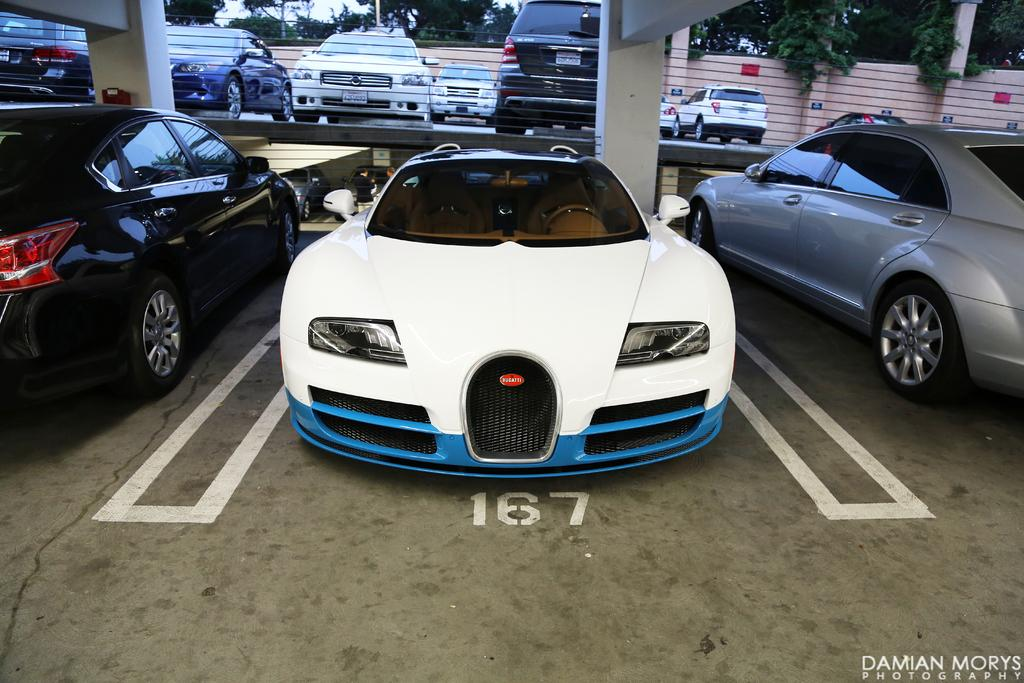What types of objects can be seen in the image? There are vehicles, pillars, a wall, boards, poles, trees, and text visible in the image. What part of the image is visible beneath the objects? The floor is visible in the image. What is present in the background of the image? The sky is visible in the image. Can you describe the text written at the bottom of the image? Unfortunately, the specific content of the text cannot be determined from the provided facts. How many beds are visible in the image? There are no beds present in the image. What type of clothing is worn by the trees in the image? Trees do not wear clothing, so this question cannot be answered. 